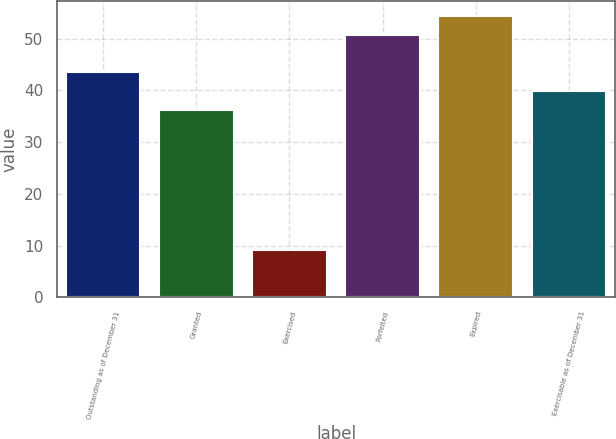<chart> <loc_0><loc_0><loc_500><loc_500><bar_chart><fcel>Outstanding as of December 31<fcel>Granted<fcel>Exercised<fcel>Forfeited<fcel>Expired<fcel>Exercisable as of December 31<nl><fcel>43.48<fcel>36.14<fcel>9.09<fcel>50.82<fcel>54.49<fcel>39.81<nl></chart> 